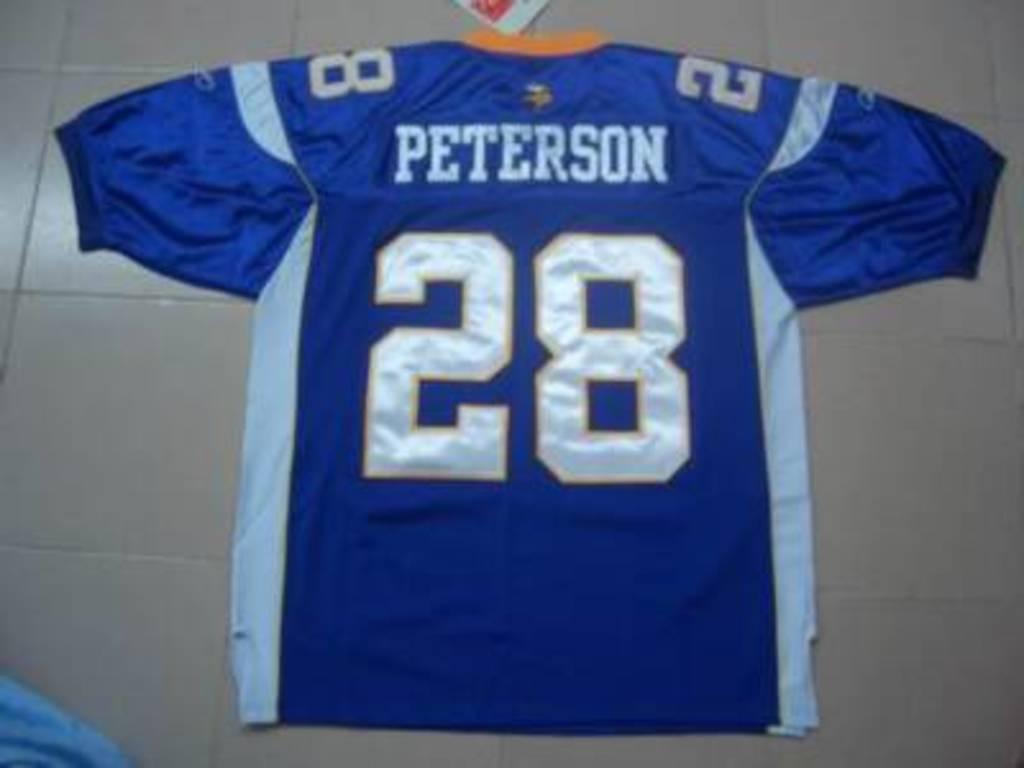Who is the jersey for?
Your answer should be very brief. Peterson. How do you write out the numbers on the jersey in words?
Offer a terse response. Twenty eight. 